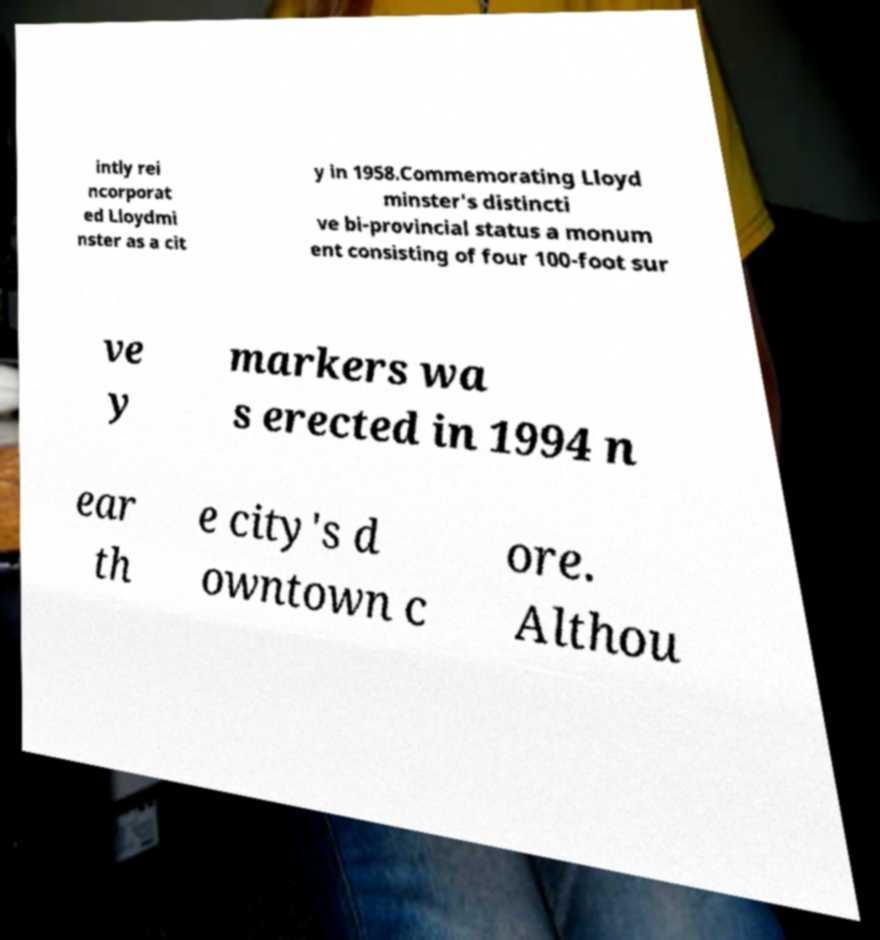Please identify and transcribe the text found in this image. intly rei ncorporat ed Lloydmi nster as a cit y in 1958.Commemorating Lloyd minster's distincti ve bi-provincial status a monum ent consisting of four 100-foot sur ve y markers wa s erected in 1994 n ear th e city's d owntown c ore. Althou 